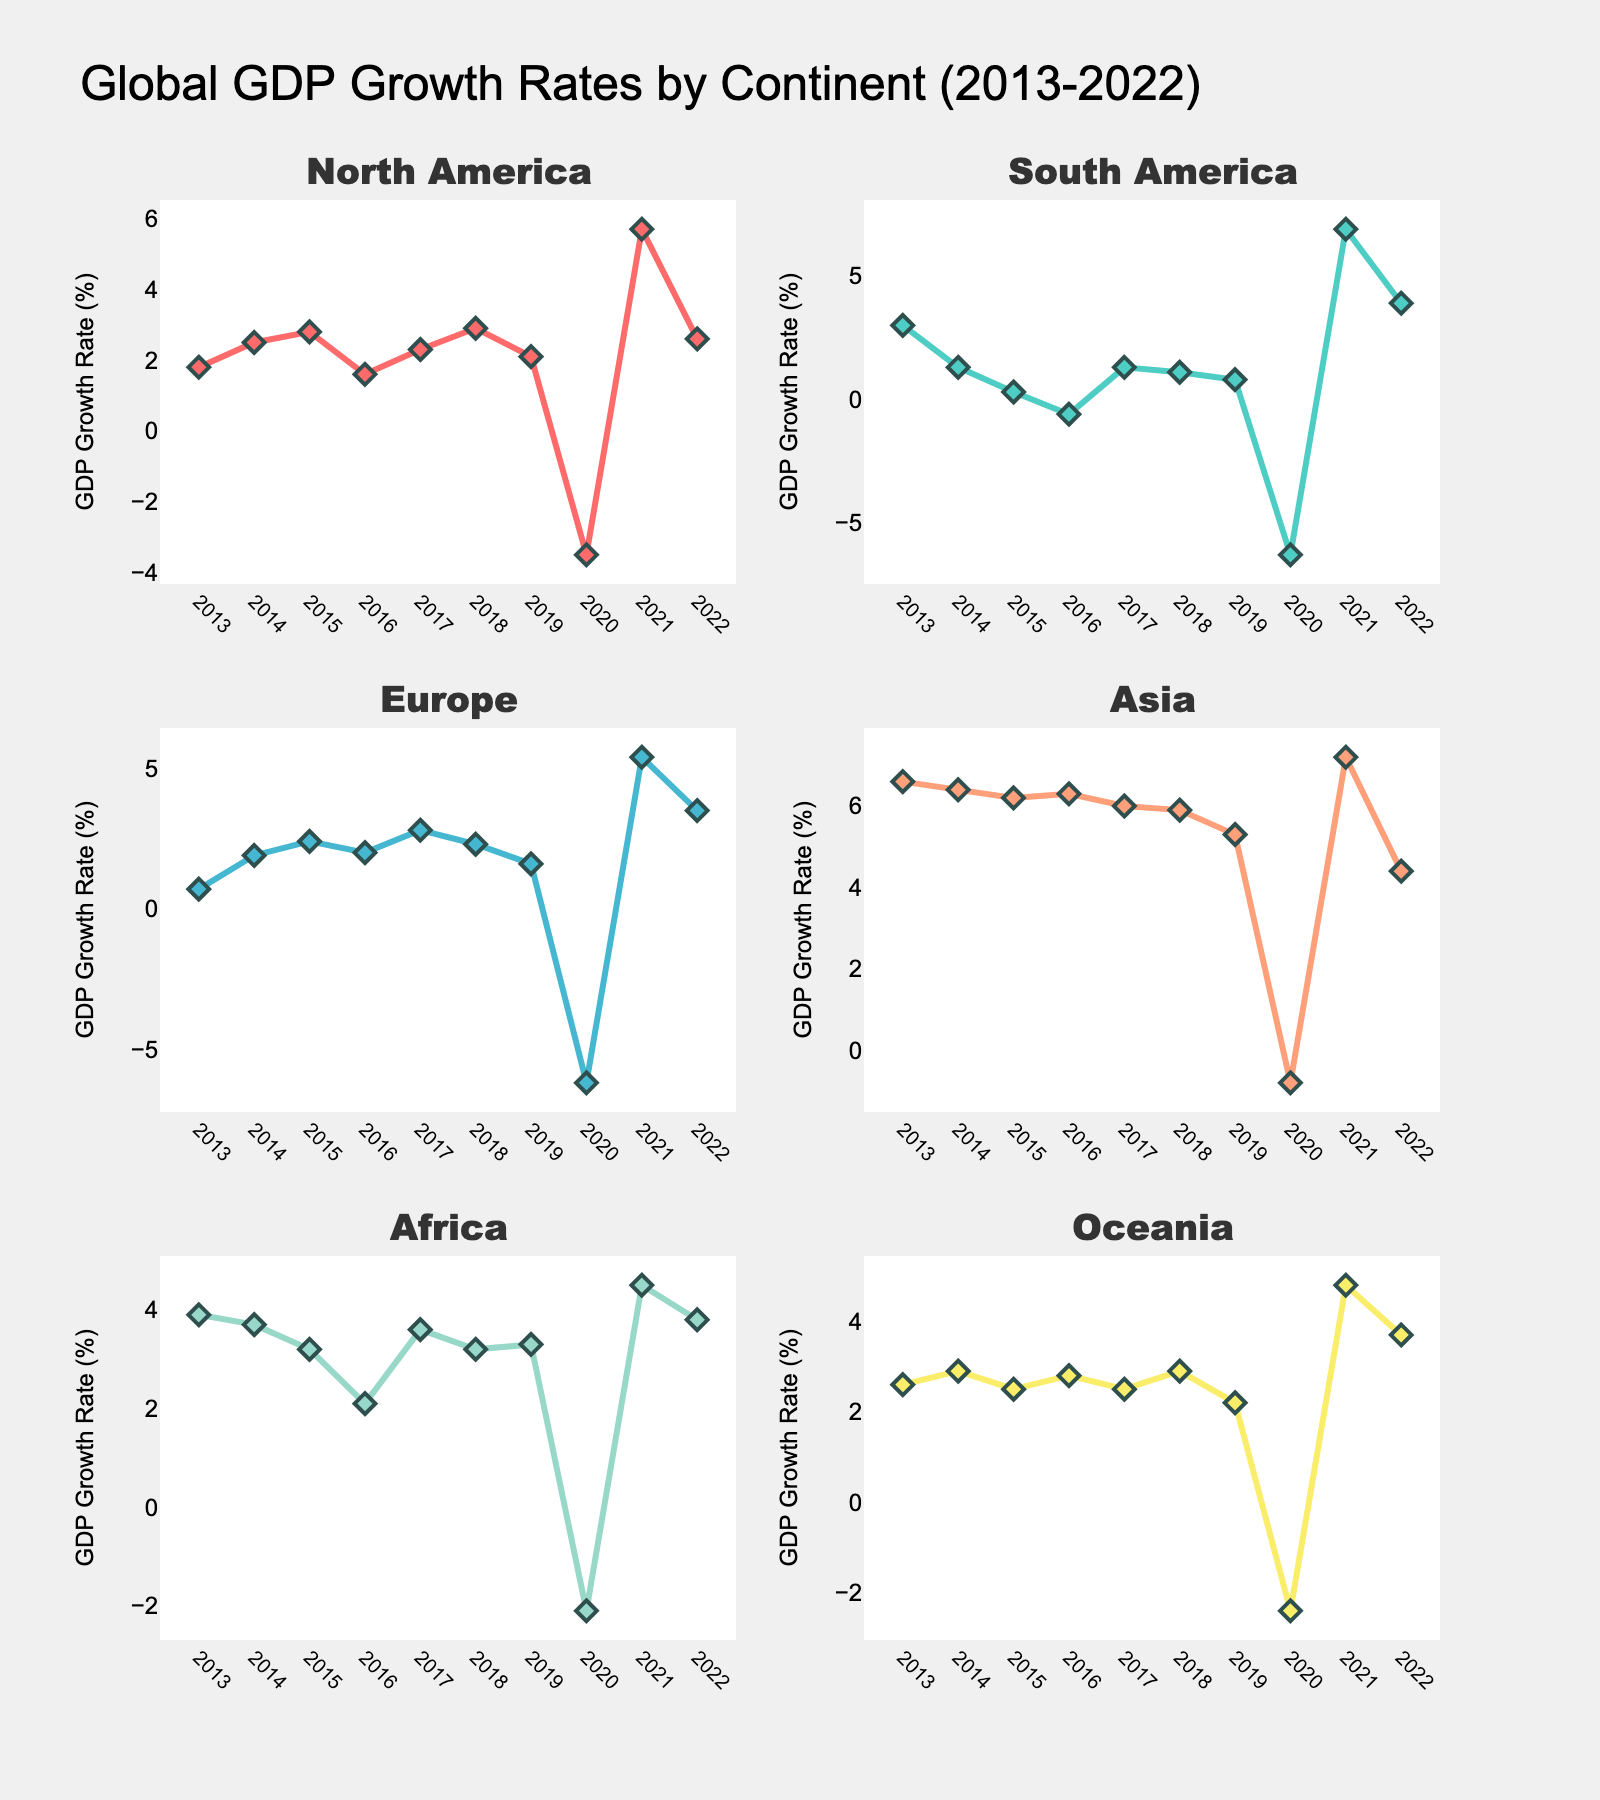What is the overall title of the figure? The overall title of the figure can be found at the top and summarizes the subject of the data shown in the plots. The title states, "Global GDP Growth Rates by Continent (2013-2022)."
Answer: Global GDP Growth Rates by Continent (2013-2022) What is the GDP growth rate for North America in 2020? Look at the subplot for North America and identify the data point corresponding to the year 2020. The plot shows a significant dip with a value of -3.5.
Answer: -3.5 Which continent had the highest GDP growth rate in 2021, and what was the rate? Scan each subplot for the year 2021 and compare the peaks. Asia has the highest value in 2021, with a rate of 7.2%.
Answer: Asia, 7.2% How did Europe's GDP growth rate change from 2020 to 2021? Examine the Europe subplot and note the GDP growth rates for 2020 and 2021. In 2020, Europe's rate was -6.2, and in 2021, it was 5.4. The change is calculated as 5.4 - (-6.2) = 11.6.
Answer: Increased by 11.6 Which continent experienced negative GDP growth rates during the year 2020? Check each subplot for the year 2020 and note which continents have negative values. North America, South America, Europe, Asia, Africa, and Oceania all had negative GDP growth rates in 2020.
Answer: All continents What is the average GDP growth rate for Asia from 2013 to 2022? Sum all the growth rates for Asia from 2013 to 2022 and then divide by the number of years. The values are 6.6, 6.4, 6.2, 6.3, 6.0, 5.9, 5.3, -0.8, 7.2, 4.4. The sum is 53.5, and the average is 53.5/10 = 5.35.
Answer: 5.35 Compare the GDP growth rates of Africa and Oceania in 2022. Which continent had a higher growth rate? Look at the data points for Africa and Oceania in 2022 in their respective subplots. Africa's rate is 3.8, whereas Oceania's rate is 3.7.
Answer: Africa How did the GDP growth rate for South America vary between 2019 and 2020? Refer to the South America subplot and note the growth rates for 2019 and 2020. In 2019, the rate was 0.8, and in 2020, it was -6.3. Calculate the difference as -6.3 - 0.8 = -7.1.
Answer: Decreased by 7.1 Which continent showed the most stability in GDP growth rates over the past decade? Analyze all the subplots to identify the continent with the least fluctuations or changes in GDP growth rates. North America and Africa show relatively stable growth rates compared to other continents. However, Africa appears slightly more stable.
Answer: Africa 